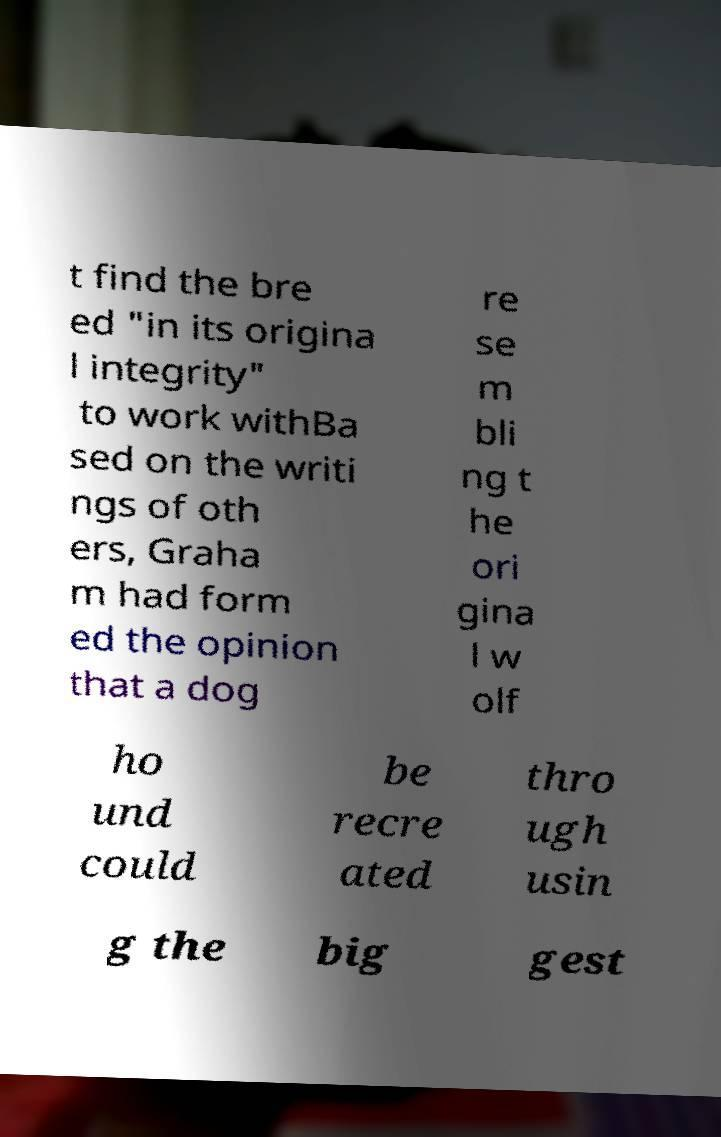Could you extract and type out the text from this image? t find the bre ed "in its origina l integrity" to work withBa sed on the writi ngs of oth ers, Graha m had form ed the opinion that a dog re se m bli ng t he ori gina l w olf ho und could be recre ated thro ugh usin g the big gest 